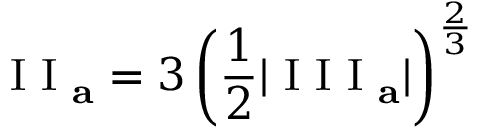Convert formula to latex. <formula><loc_0><loc_0><loc_500><loc_500>I I _ { a } = 3 \left ( \frac { 1 } { 2 } | I I I _ { a } | \right ) ^ { \frac { 2 } { 3 } }</formula> 